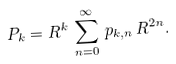Convert formula to latex. <formula><loc_0><loc_0><loc_500><loc_500>P _ { k } = R ^ { k } \, \sum _ { n = 0 } ^ { \infty } \, p _ { k , n } \, R ^ { 2 n } .</formula> 